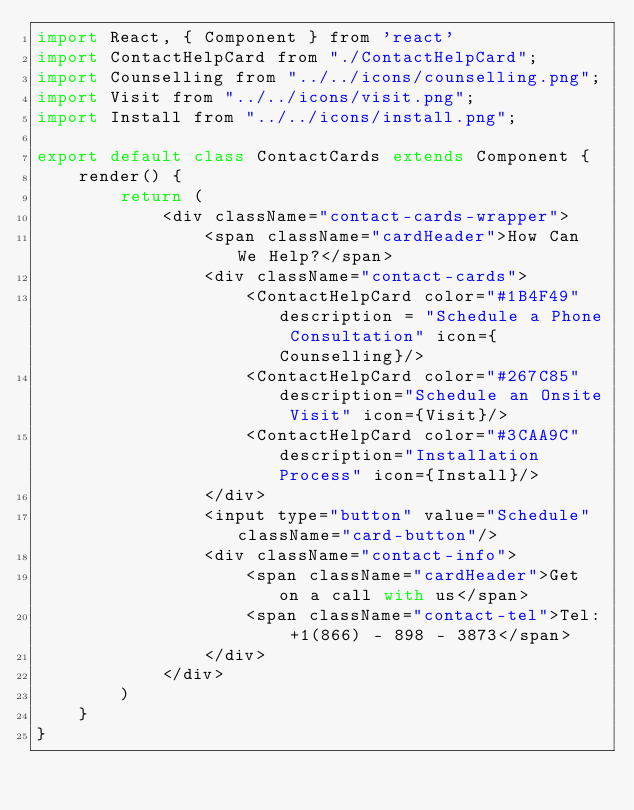<code> <loc_0><loc_0><loc_500><loc_500><_JavaScript_>import React, { Component } from 'react'
import ContactHelpCard from "./ContactHelpCard";
import Counselling from "../../icons/counselling.png";
import Visit from "../../icons/visit.png";
import Install from "../../icons/install.png";

export default class ContactCards extends Component {
    render() {
        return (
            <div className="contact-cards-wrapper">
                <span className="cardHeader">How Can We Help?</span>
                <div className="contact-cards">
                    <ContactHelpCard color="#1B4F49" description = "Schedule a Phone Consultation" icon={Counselling}/>
                    <ContactHelpCard color="#267C85" description="Schedule an Onsite Visit" icon={Visit}/>
                    <ContactHelpCard color="#3CAA9C" description="Installation Process" icon={Install}/>
                </div>
                <input type="button" value="Schedule" className="card-button"/>
                <div className="contact-info">
                    <span className="cardHeader">Get on a call with us</span>
                    <span className="contact-tel">Tel: +1(866) - 898 - 3873</span>
                </div>    
            </div>
        )
    }
}
</code> 